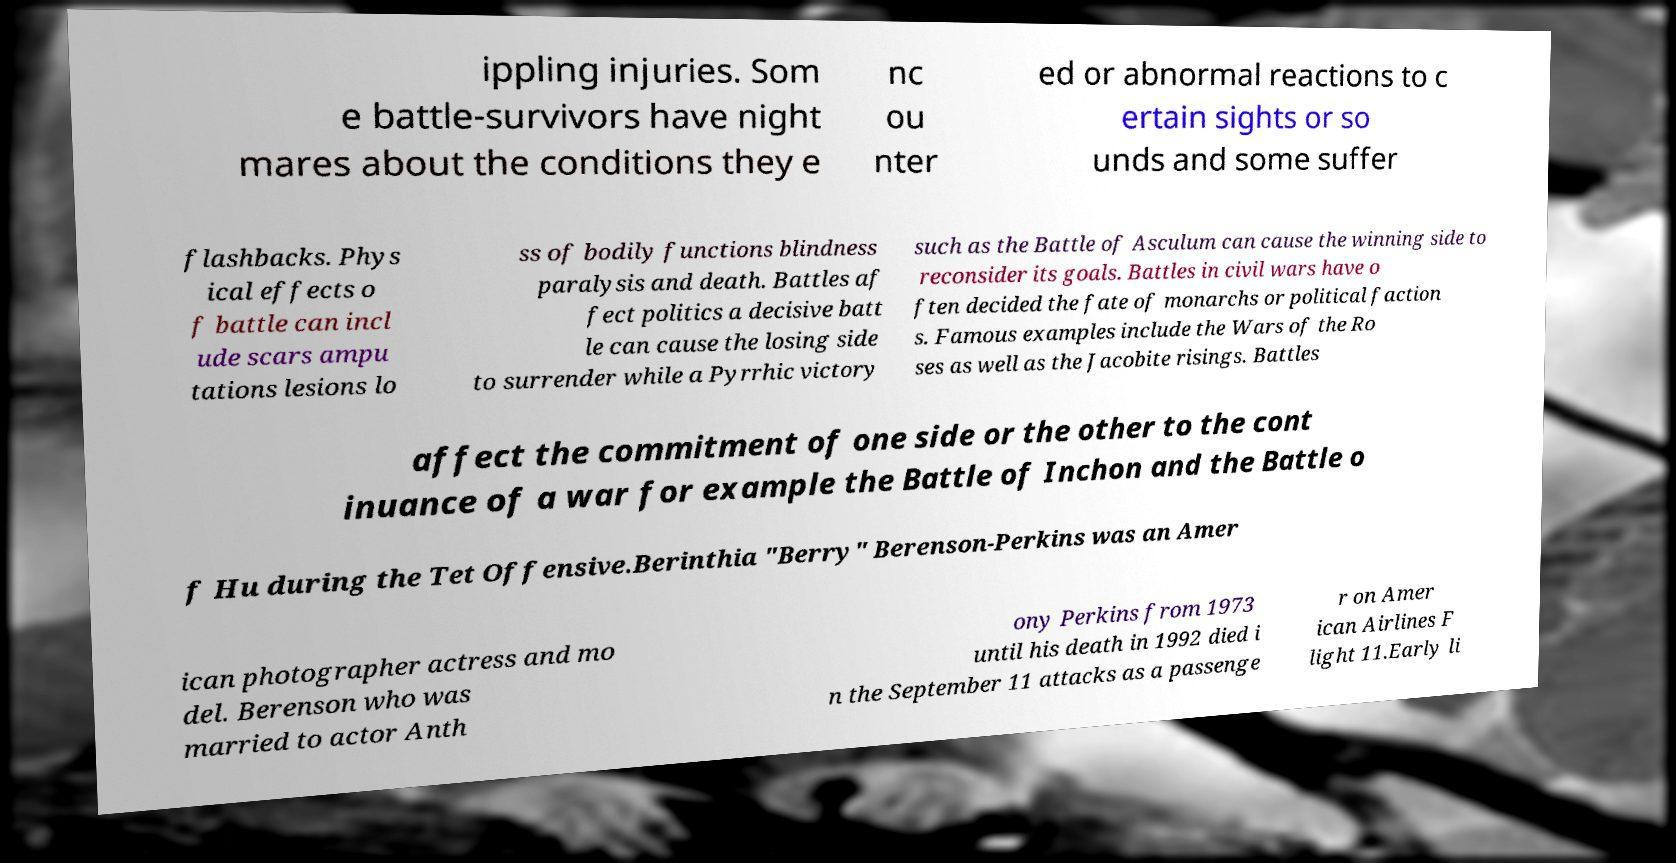There's text embedded in this image that I need extracted. Can you transcribe it verbatim? ippling injuries. Som e battle-survivors have night mares about the conditions they e nc ou nter ed or abnormal reactions to c ertain sights or so unds and some suffer flashbacks. Phys ical effects o f battle can incl ude scars ampu tations lesions lo ss of bodily functions blindness paralysis and death. Battles af fect politics a decisive batt le can cause the losing side to surrender while a Pyrrhic victory such as the Battle of Asculum can cause the winning side to reconsider its goals. Battles in civil wars have o ften decided the fate of monarchs or political faction s. Famous examples include the Wars of the Ro ses as well as the Jacobite risings. Battles affect the commitment of one side or the other to the cont inuance of a war for example the Battle of Inchon and the Battle o f Hu during the Tet Offensive.Berinthia "Berry" Berenson-Perkins was an Amer ican photographer actress and mo del. Berenson who was married to actor Anth ony Perkins from 1973 until his death in 1992 died i n the September 11 attacks as a passenge r on Amer ican Airlines F light 11.Early li 